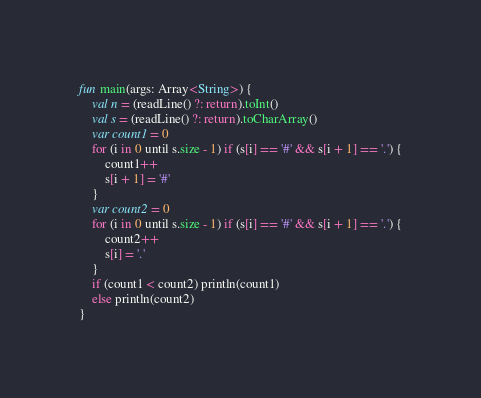Convert code to text. <code><loc_0><loc_0><loc_500><loc_500><_Kotlin_>fun main(args: Array<String>) {
	val n = (readLine() ?: return).toInt()
	val s = (readLine() ?: return).toCharArray()
	var count1 = 0
	for (i in 0 until s.size - 1) if (s[i] == '#' && s[i + 1] == '.') {
		count1++
		s[i + 1] = '#'
	}
	var count2 = 0
	for (i in 0 until s.size - 1) if (s[i] == '#' && s[i + 1] == '.') {
		count2++
		s[i] = '.'
	}
	if (count1 < count2) println(count1)
	else println(count2)
}</code> 